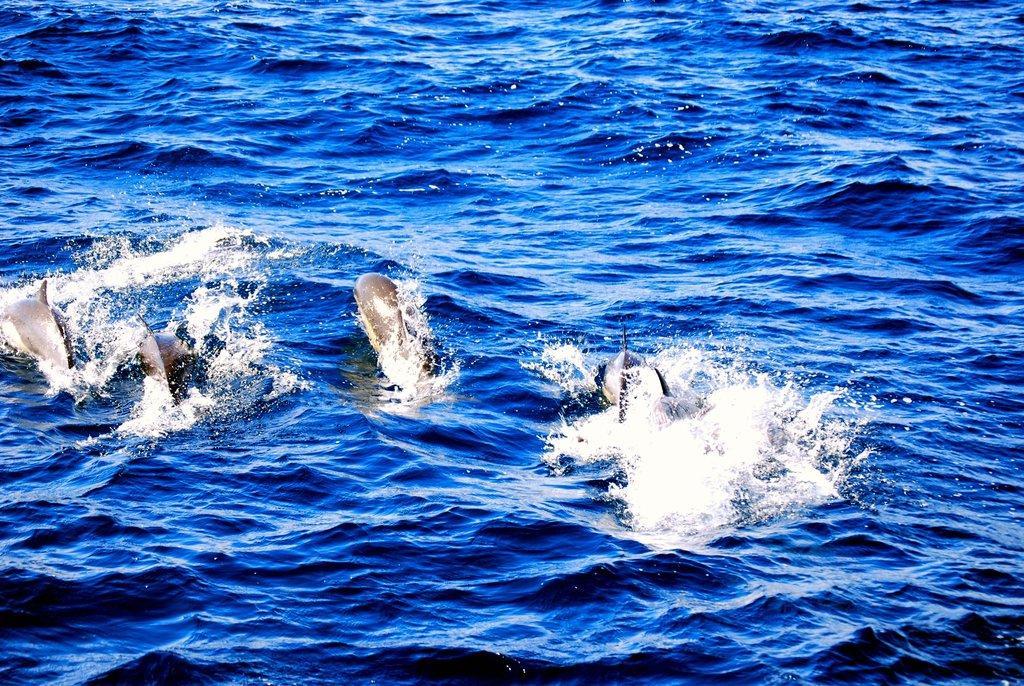Describe this image in one or two sentences. This picture is clicked outside the city. In the center we can see the sea animals in the water body and we can see the ripples in the water body. 